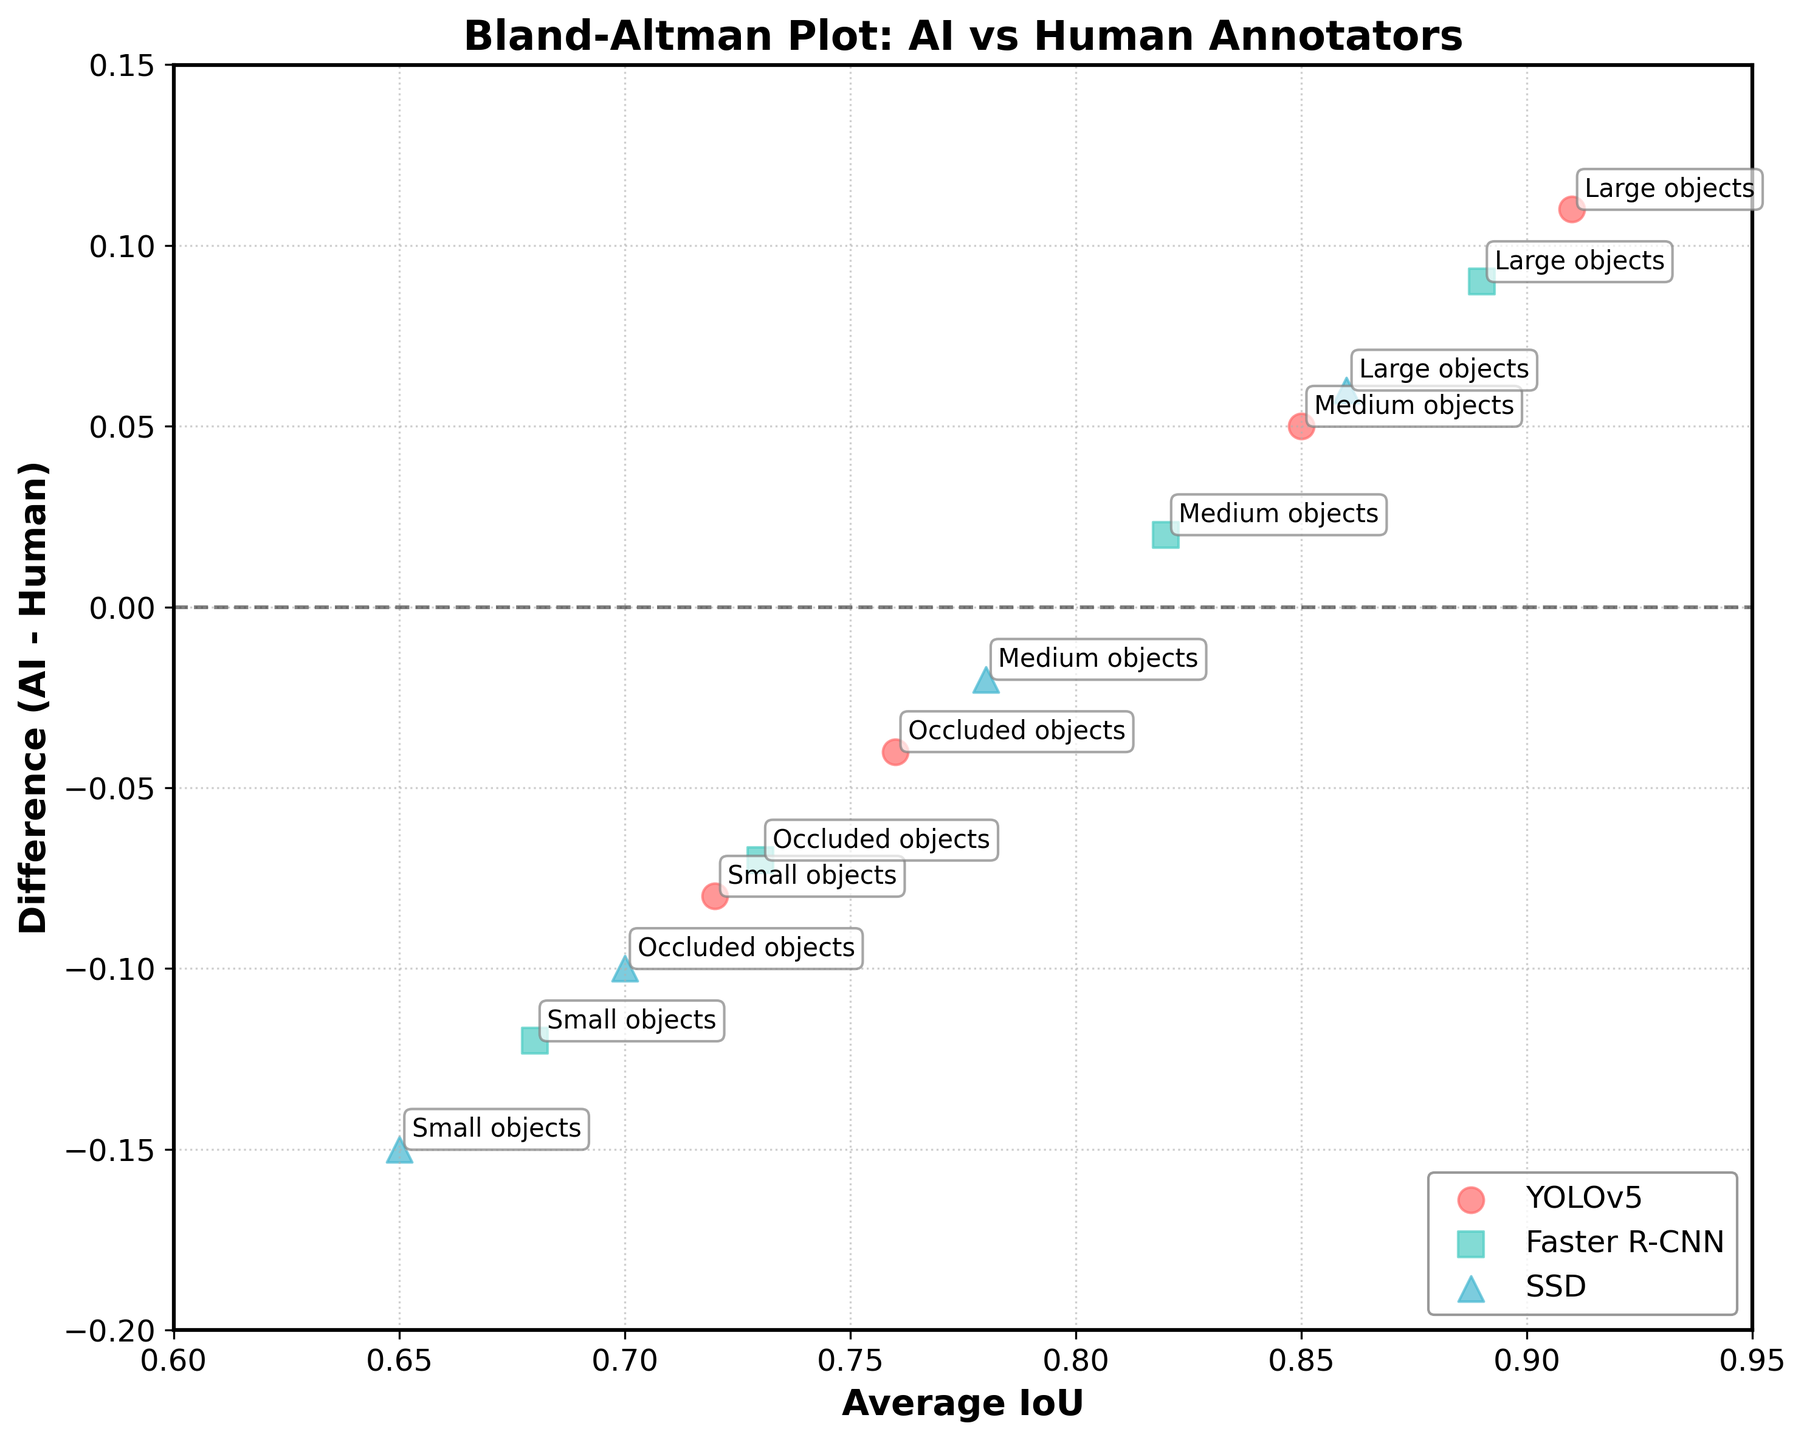What is the title of the plot? The title of the plot is displayed at the top, which is "Bland-Altman Plot: AI vs Human Annotators".
Answer: Bland-Altman Plot: AI vs Human Annotators What does the y-axis represent? The y-axis is labeled as "Difference (AI - Human)", so it represents the difference in IoU (Intersection over Union) between the AI model and the human annotator.
Answer: Difference (AI - Human) What is the marker color and shape representing the YOLOv5 model? The YOLOv5 model is represented by red circular markers as shown in the legend of the plot.
Answer: red circular markers How many data points are plotted for the SSD model? According to the legend, the SSD model has data points for small, medium, large, and occluded objects, which totals to four data points.
Answer: 4 Which object category shows the highest consistency between human annotators and the YOLOv5 model? Consistency is highest for large objects as indicated by the data point with the highest average IoU of 0.91 and a difference of 0.11.
Answer: Large objects Between which models and for which object size is the difference (AI - Human) the lowest? By examining the y-axis values, the medium objects category with YOLOv5 has the lowest positive difference of 0.05.
Answer: YOLOv5 with medium objects Which model has the largest negative difference for small objects? Among the small objects, SSD has the largest negative difference of -0.15.
Answer: SSD Compare the difference values for Faster R-CNN across all object sizes. Which object size shows the smallest discrepancy? By comparing the y-values, medium objects show the smallest discrepancy with a difference of 0.02 for Faster R-CNN.
Answer: Medium objects What is the average difference value for the SSD model across all object sizes? The difference values for SSD are -0.15, -0.02, 0.06, and -0.10. Summing these gives -0.21, and the average is -0.21/4 = -0.0525.
Answer: -0.0525 Which model-category combination is closest to the y=0 line, indicating the closest agreement between AI and Human? The medium objects category for Faster R-CNN, with a difference of 0.02, is closest to the y=0 line, indicating close agreement.
Answer: Faster R-CNN with medium objects 